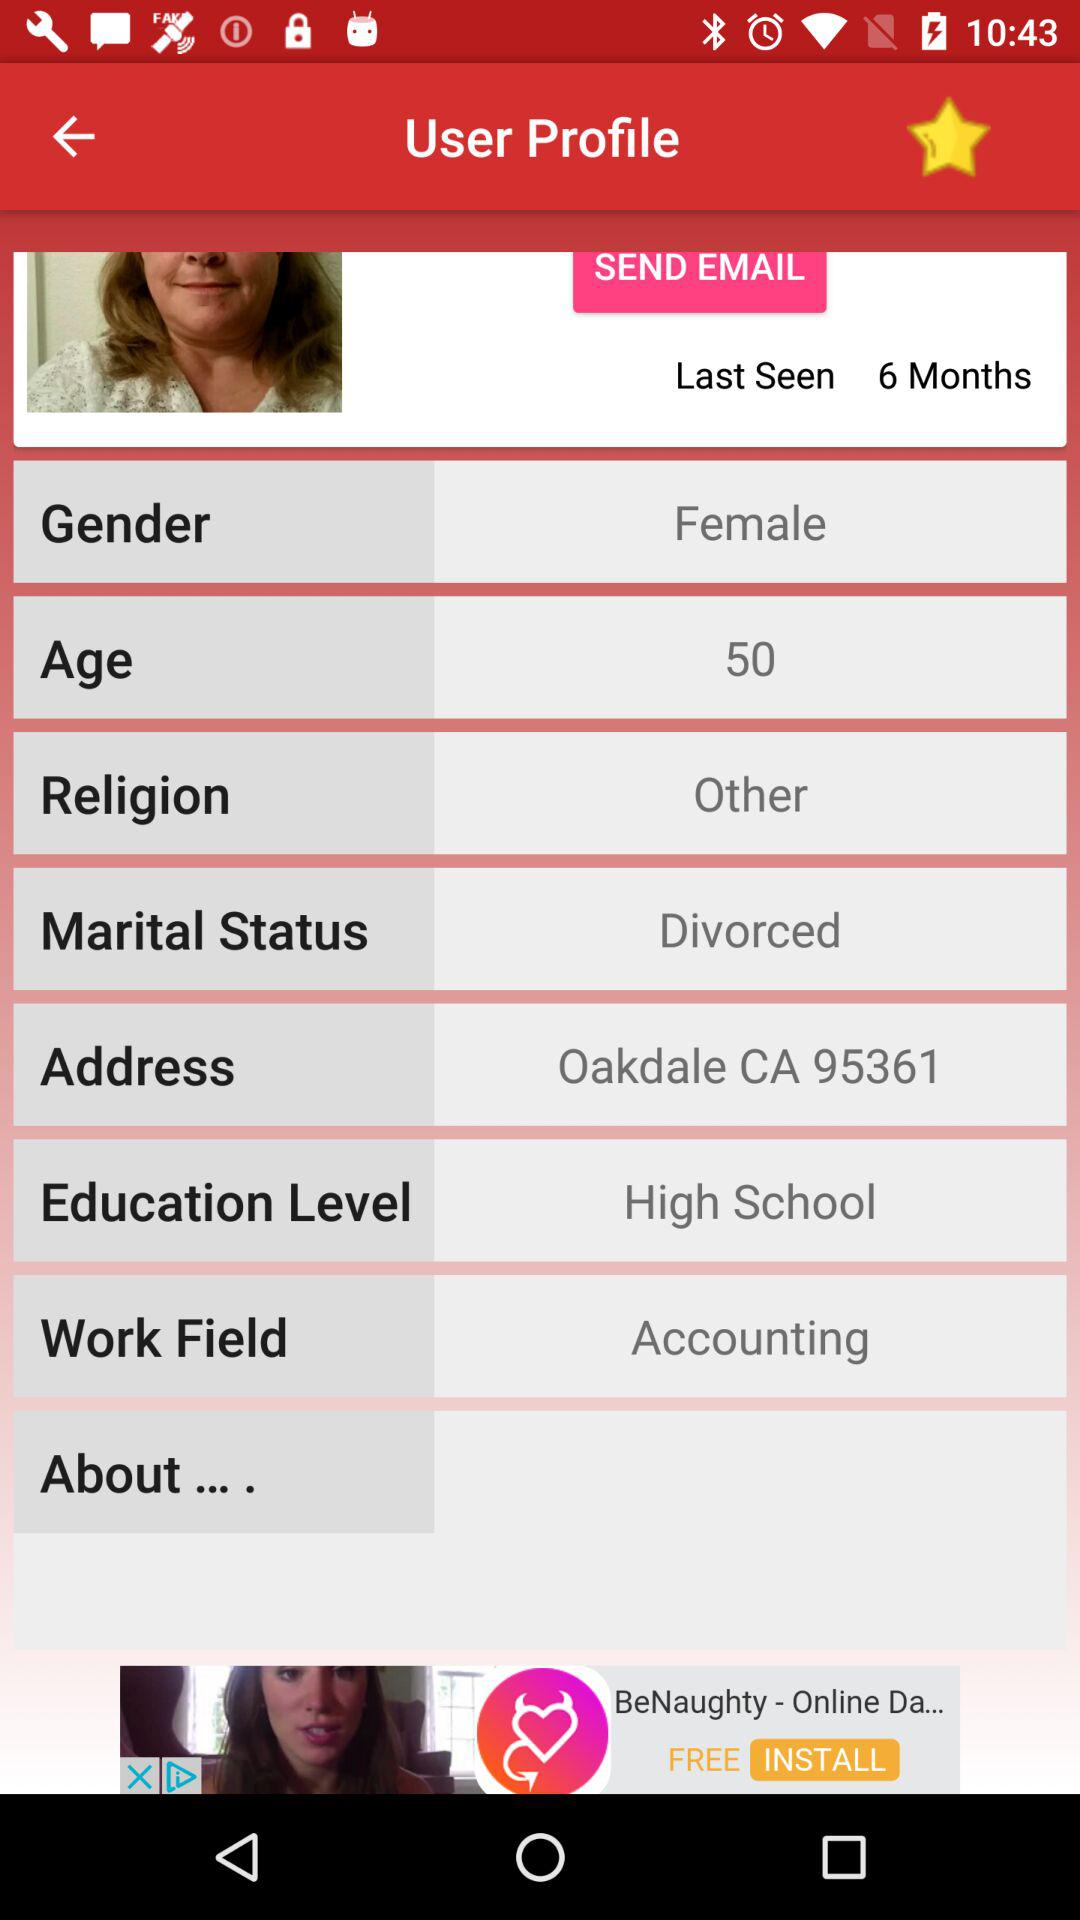What is the age and gender? The age is 50 years old and the gender is female. 